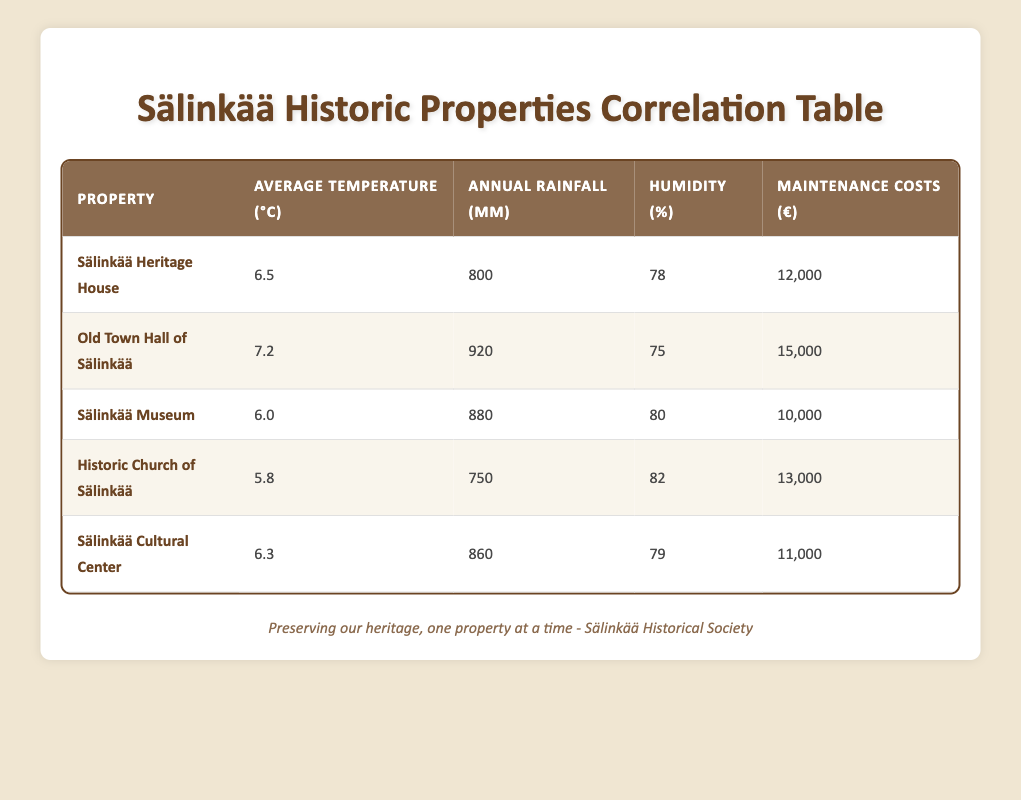What is the maintenance cost of the Sälinkää Heritage House? According to the table, the maintenance cost for the Sälinkää Heritage House is explicitly stated as 12,000 euros.
Answer: 12,000 euros Which property has the highest average temperature? By comparing the average temperature values listed in the table, the Old Town Hall of Sälinkää has the highest temperature at 7.2 degrees Celsius.
Answer: Old Town Hall of Sälinkää What is the average humidity of all the properties listed? To find the average humidity, sum the humidity percentages of each property: (78 + 75 + 80 + 82 + 79) = 394. Then divide by the number of properties (5): 394/5 = 78.8.
Answer: 78.8 Is the maintenance cost of the Historic Church of Sälinkää more than that of the Sälinkää Museum? The maintenance cost for the Historic Church of Sälinkää is 13,000 euros, while the Sälinkää Museum has a cost of 10,000 euros. Since 13,000 is greater than 10,000, the statement is true.
Answer: Yes Which property has the lowest annual rainfall, and what is that amount? Reviewing the annual rainfall figures, the Historic Church of Sälinkää has the lowest amount at 750 mm.
Answer: Historic Church of Sälinkää, 750 mm What is the total maintenance cost of all the properties? To find the total maintenance cost, add all individual maintenance costs: (12,000 + 15,000 + 10,000 + 13,000 + 11,000) = 61,000 euros for all properties combined.
Answer: 61,000 euros Does higher humidity correlate with higher maintenance costs in the listed properties? By examining the data, the property with the highest humidity (Historic Church of Sälinkää at 82%) has a maintenance cost of 13,000 euros, while the property with the lowest humidity (Old Town Hall of Sälinkää at 75%) costs 15,000 euros. This shows that higher humidity does not consistently lead to higher costs.
Answer: No Which property has the closest maintenance costs to the average maintenance cost of all properties? The average maintenance cost can be calculated as 61,000 euros divided by 5, which is 12,200 euros. The property with the closest maintenance cost is the Sälinkää Heritage House at 12,000 euros, which is only 200 euros lower.
Answer: Sälinkää Heritage House What is the difference in maintenance costs between the Old Town Hall of Sälinkää and the Sälinkää Cultural Center? The Old Town Hall of Sälinkää maintains costs of 15,000 euros, while the Sälinkää Cultural Center has costs of 11,000 euros. The difference is calculated as: 15,000 - 11,000 = 4,000 euros.
Answer: 4,000 euros 